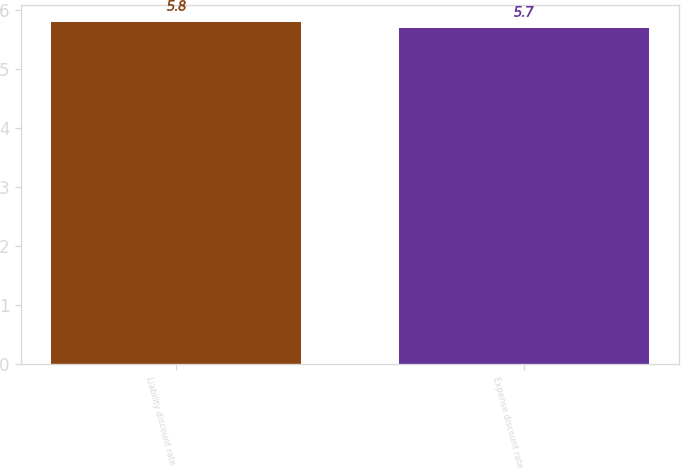<chart> <loc_0><loc_0><loc_500><loc_500><bar_chart><fcel>Liability discount rate<fcel>Expense discount rate<nl><fcel>5.8<fcel>5.7<nl></chart> 